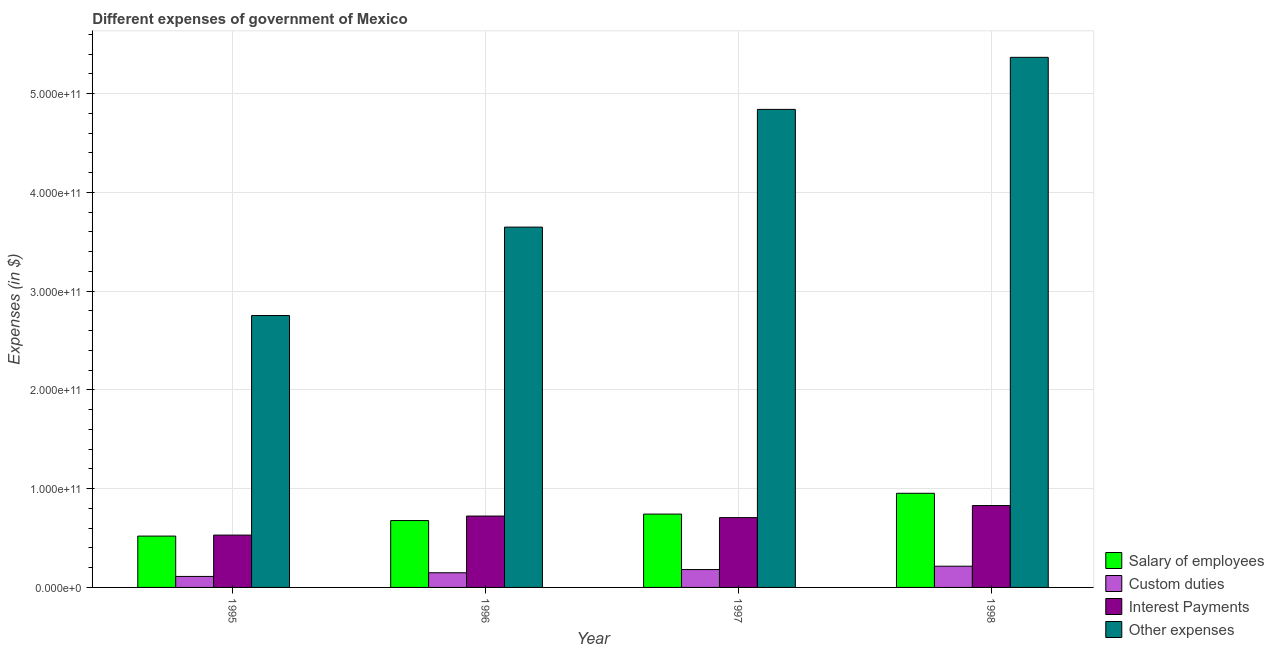How many different coloured bars are there?
Your answer should be very brief. 4. How many groups of bars are there?
Offer a terse response. 4. Are the number of bars per tick equal to the number of legend labels?
Give a very brief answer. Yes. Are the number of bars on each tick of the X-axis equal?
Your answer should be compact. Yes. How many bars are there on the 1st tick from the right?
Ensure brevity in your answer.  4. What is the label of the 1st group of bars from the left?
Provide a succinct answer. 1995. What is the amount spent on salary of employees in 1998?
Your response must be concise. 9.53e+1. Across all years, what is the maximum amount spent on interest payments?
Give a very brief answer. 8.29e+1. Across all years, what is the minimum amount spent on custom duties?
Your response must be concise. 1.11e+1. What is the total amount spent on custom duties in the graph?
Make the answer very short. 6.56e+1. What is the difference between the amount spent on salary of employees in 1997 and that in 1998?
Provide a short and direct response. -2.11e+1. What is the difference between the amount spent on salary of employees in 1995 and the amount spent on other expenses in 1998?
Your response must be concise. -4.33e+1. What is the average amount spent on custom duties per year?
Your answer should be compact. 1.64e+1. In the year 1998, what is the difference between the amount spent on other expenses and amount spent on custom duties?
Your response must be concise. 0. What is the ratio of the amount spent on custom duties in 1996 to that in 1997?
Offer a very short reply. 0.82. Is the amount spent on interest payments in 1995 less than that in 1998?
Your answer should be compact. Yes. Is the difference between the amount spent on other expenses in 1996 and 1998 greater than the difference between the amount spent on interest payments in 1996 and 1998?
Make the answer very short. No. What is the difference between the highest and the second highest amount spent on salary of employees?
Offer a terse response. 2.11e+1. What is the difference between the highest and the lowest amount spent on custom duties?
Your answer should be very brief. 1.03e+1. Is the sum of the amount spent on salary of employees in 1997 and 1998 greater than the maximum amount spent on other expenses across all years?
Keep it short and to the point. Yes. What does the 2nd bar from the left in 1998 represents?
Your answer should be very brief. Custom duties. What does the 1st bar from the right in 1998 represents?
Provide a succinct answer. Other expenses. Is it the case that in every year, the sum of the amount spent on salary of employees and amount spent on custom duties is greater than the amount spent on interest payments?
Offer a very short reply. Yes. How many bars are there?
Your answer should be very brief. 16. What is the difference between two consecutive major ticks on the Y-axis?
Provide a succinct answer. 1.00e+11. Does the graph contain any zero values?
Provide a short and direct response. No. Where does the legend appear in the graph?
Provide a succinct answer. Bottom right. What is the title of the graph?
Give a very brief answer. Different expenses of government of Mexico. Does "Quality Certification" appear as one of the legend labels in the graph?
Keep it short and to the point. No. What is the label or title of the X-axis?
Your answer should be compact. Year. What is the label or title of the Y-axis?
Make the answer very short. Expenses (in $). What is the Expenses (in $) of Salary of employees in 1995?
Keep it short and to the point. 5.20e+1. What is the Expenses (in $) in Custom duties in 1995?
Your answer should be compact. 1.11e+1. What is the Expenses (in $) of Interest Payments in 1995?
Offer a terse response. 5.30e+1. What is the Expenses (in $) of Other expenses in 1995?
Provide a short and direct response. 2.75e+11. What is the Expenses (in $) of Salary of employees in 1996?
Offer a very short reply. 6.77e+1. What is the Expenses (in $) of Custom duties in 1996?
Ensure brevity in your answer.  1.49e+1. What is the Expenses (in $) in Interest Payments in 1996?
Provide a short and direct response. 7.23e+1. What is the Expenses (in $) of Other expenses in 1996?
Provide a short and direct response. 3.65e+11. What is the Expenses (in $) of Salary of employees in 1997?
Your answer should be compact. 7.43e+1. What is the Expenses (in $) in Custom duties in 1997?
Offer a very short reply. 1.81e+1. What is the Expenses (in $) of Interest Payments in 1997?
Keep it short and to the point. 7.07e+1. What is the Expenses (in $) of Other expenses in 1997?
Give a very brief answer. 4.84e+11. What is the Expenses (in $) of Salary of employees in 1998?
Make the answer very short. 9.53e+1. What is the Expenses (in $) of Custom duties in 1998?
Your answer should be very brief. 2.15e+1. What is the Expenses (in $) in Interest Payments in 1998?
Your response must be concise. 8.29e+1. What is the Expenses (in $) of Other expenses in 1998?
Your answer should be very brief. 5.37e+11. Across all years, what is the maximum Expenses (in $) in Salary of employees?
Provide a short and direct response. 9.53e+1. Across all years, what is the maximum Expenses (in $) in Custom duties?
Provide a short and direct response. 2.15e+1. Across all years, what is the maximum Expenses (in $) in Interest Payments?
Your response must be concise. 8.29e+1. Across all years, what is the maximum Expenses (in $) of Other expenses?
Ensure brevity in your answer.  5.37e+11. Across all years, what is the minimum Expenses (in $) in Salary of employees?
Offer a terse response. 5.20e+1. Across all years, what is the minimum Expenses (in $) of Custom duties?
Provide a short and direct response. 1.11e+1. Across all years, what is the minimum Expenses (in $) in Interest Payments?
Offer a very short reply. 5.30e+1. Across all years, what is the minimum Expenses (in $) in Other expenses?
Your response must be concise. 2.75e+11. What is the total Expenses (in $) in Salary of employees in the graph?
Give a very brief answer. 2.89e+11. What is the total Expenses (in $) of Custom duties in the graph?
Provide a succinct answer. 6.56e+1. What is the total Expenses (in $) of Interest Payments in the graph?
Provide a short and direct response. 2.79e+11. What is the total Expenses (in $) in Other expenses in the graph?
Provide a short and direct response. 1.66e+12. What is the difference between the Expenses (in $) of Salary of employees in 1995 and that in 1996?
Ensure brevity in your answer.  -1.57e+1. What is the difference between the Expenses (in $) in Custom duties in 1995 and that in 1996?
Your answer should be very brief. -3.71e+09. What is the difference between the Expenses (in $) in Interest Payments in 1995 and that in 1996?
Your response must be concise. -1.93e+1. What is the difference between the Expenses (in $) in Other expenses in 1995 and that in 1996?
Your answer should be compact. -8.95e+1. What is the difference between the Expenses (in $) in Salary of employees in 1995 and that in 1997?
Ensure brevity in your answer.  -2.23e+1. What is the difference between the Expenses (in $) in Custom duties in 1995 and that in 1997?
Provide a short and direct response. -6.96e+09. What is the difference between the Expenses (in $) in Interest Payments in 1995 and that in 1997?
Make the answer very short. -1.77e+1. What is the difference between the Expenses (in $) in Other expenses in 1995 and that in 1997?
Make the answer very short. -2.09e+11. What is the difference between the Expenses (in $) of Salary of employees in 1995 and that in 1998?
Offer a terse response. -4.33e+1. What is the difference between the Expenses (in $) of Custom duties in 1995 and that in 1998?
Offer a very short reply. -1.03e+1. What is the difference between the Expenses (in $) of Interest Payments in 1995 and that in 1998?
Make the answer very short. -2.99e+1. What is the difference between the Expenses (in $) in Other expenses in 1995 and that in 1998?
Keep it short and to the point. -2.61e+11. What is the difference between the Expenses (in $) in Salary of employees in 1996 and that in 1997?
Make the answer very short. -6.55e+09. What is the difference between the Expenses (in $) of Custom duties in 1996 and that in 1997?
Your answer should be compact. -3.25e+09. What is the difference between the Expenses (in $) of Interest Payments in 1996 and that in 1997?
Provide a succinct answer. 1.58e+09. What is the difference between the Expenses (in $) in Other expenses in 1996 and that in 1997?
Offer a very short reply. -1.19e+11. What is the difference between the Expenses (in $) of Salary of employees in 1996 and that in 1998?
Offer a very short reply. -2.76e+1. What is the difference between the Expenses (in $) of Custom duties in 1996 and that in 1998?
Make the answer very short. -6.63e+09. What is the difference between the Expenses (in $) of Interest Payments in 1996 and that in 1998?
Provide a short and direct response. -1.06e+1. What is the difference between the Expenses (in $) of Other expenses in 1996 and that in 1998?
Keep it short and to the point. -1.72e+11. What is the difference between the Expenses (in $) of Salary of employees in 1997 and that in 1998?
Your answer should be very brief. -2.11e+1. What is the difference between the Expenses (in $) of Custom duties in 1997 and that in 1998?
Your response must be concise. -3.38e+09. What is the difference between the Expenses (in $) in Interest Payments in 1997 and that in 1998?
Your answer should be very brief. -1.22e+1. What is the difference between the Expenses (in $) of Other expenses in 1997 and that in 1998?
Ensure brevity in your answer.  -5.27e+1. What is the difference between the Expenses (in $) in Salary of employees in 1995 and the Expenses (in $) in Custom duties in 1996?
Ensure brevity in your answer.  3.71e+1. What is the difference between the Expenses (in $) of Salary of employees in 1995 and the Expenses (in $) of Interest Payments in 1996?
Give a very brief answer. -2.03e+1. What is the difference between the Expenses (in $) in Salary of employees in 1995 and the Expenses (in $) in Other expenses in 1996?
Provide a short and direct response. -3.13e+11. What is the difference between the Expenses (in $) of Custom duties in 1995 and the Expenses (in $) of Interest Payments in 1996?
Ensure brevity in your answer.  -6.11e+1. What is the difference between the Expenses (in $) of Custom duties in 1995 and the Expenses (in $) of Other expenses in 1996?
Keep it short and to the point. -3.54e+11. What is the difference between the Expenses (in $) in Interest Payments in 1995 and the Expenses (in $) in Other expenses in 1996?
Your answer should be very brief. -3.12e+11. What is the difference between the Expenses (in $) in Salary of employees in 1995 and the Expenses (in $) in Custom duties in 1997?
Your answer should be very brief. 3.39e+1. What is the difference between the Expenses (in $) of Salary of employees in 1995 and the Expenses (in $) of Interest Payments in 1997?
Your answer should be very brief. -1.87e+1. What is the difference between the Expenses (in $) in Salary of employees in 1995 and the Expenses (in $) in Other expenses in 1997?
Provide a short and direct response. -4.32e+11. What is the difference between the Expenses (in $) of Custom duties in 1995 and the Expenses (in $) of Interest Payments in 1997?
Offer a terse response. -5.96e+1. What is the difference between the Expenses (in $) of Custom duties in 1995 and the Expenses (in $) of Other expenses in 1997?
Your answer should be compact. -4.73e+11. What is the difference between the Expenses (in $) of Interest Payments in 1995 and the Expenses (in $) of Other expenses in 1997?
Your answer should be compact. -4.31e+11. What is the difference between the Expenses (in $) in Salary of employees in 1995 and the Expenses (in $) in Custom duties in 1998?
Provide a succinct answer. 3.05e+1. What is the difference between the Expenses (in $) of Salary of employees in 1995 and the Expenses (in $) of Interest Payments in 1998?
Your response must be concise. -3.09e+1. What is the difference between the Expenses (in $) in Salary of employees in 1995 and the Expenses (in $) in Other expenses in 1998?
Your response must be concise. -4.85e+11. What is the difference between the Expenses (in $) in Custom duties in 1995 and the Expenses (in $) in Interest Payments in 1998?
Give a very brief answer. -7.18e+1. What is the difference between the Expenses (in $) in Custom duties in 1995 and the Expenses (in $) in Other expenses in 1998?
Give a very brief answer. -5.26e+11. What is the difference between the Expenses (in $) in Interest Payments in 1995 and the Expenses (in $) in Other expenses in 1998?
Offer a very short reply. -4.84e+11. What is the difference between the Expenses (in $) in Salary of employees in 1996 and the Expenses (in $) in Custom duties in 1997?
Provide a short and direct response. 4.96e+1. What is the difference between the Expenses (in $) in Salary of employees in 1996 and the Expenses (in $) in Interest Payments in 1997?
Provide a succinct answer. -2.99e+09. What is the difference between the Expenses (in $) of Salary of employees in 1996 and the Expenses (in $) of Other expenses in 1997?
Offer a terse response. -4.16e+11. What is the difference between the Expenses (in $) in Custom duties in 1996 and the Expenses (in $) in Interest Payments in 1997?
Offer a very short reply. -5.59e+1. What is the difference between the Expenses (in $) in Custom duties in 1996 and the Expenses (in $) in Other expenses in 1997?
Provide a succinct answer. -4.69e+11. What is the difference between the Expenses (in $) in Interest Payments in 1996 and the Expenses (in $) in Other expenses in 1997?
Keep it short and to the point. -4.12e+11. What is the difference between the Expenses (in $) of Salary of employees in 1996 and the Expenses (in $) of Custom duties in 1998?
Your answer should be very brief. 4.62e+1. What is the difference between the Expenses (in $) in Salary of employees in 1996 and the Expenses (in $) in Interest Payments in 1998?
Give a very brief answer. -1.52e+1. What is the difference between the Expenses (in $) of Salary of employees in 1996 and the Expenses (in $) of Other expenses in 1998?
Your response must be concise. -4.69e+11. What is the difference between the Expenses (in $) of Custom duties in 1996 and the Expenses (in $) of Interest Payments in 1998?
Make the answer very short. -6.81e+1. What is the difference between the Expenses (in $) in Custom duties in 1996 and the Expenses (in $) in Other expenses in 1998?
Provide a succinct answer. -5.22e+11. What is the difference between the Expenses (in $) of Interest Payments in 1996 and the Expenses (in $) of Other expenses in 1998?
Offer a very short reply. -4.65e+11. What is the difference between the Expenses (in $) of Salary of employees in 1997 and the Expenses (in $) of Custom duties in 1998?
Provide a succinct answer. 5.28e+1. What is the difference between the Expenses (in $) in Salary of employees in 1997 and the Expenses (in $) in Interest Payments in 1998?
Make the answer very short. -8.64e+09. What is the difference between the Expenses (in $) of Salary of employees in 1997 and the Expenses (in $) of Other expenses in 1998?
Offer a terse response. -4.63e+11. What is the difference between the Expenses (in $) of Custom duties in 1997 and the Expenses (in $) of Interest Payments in 1998?
Make the answer very short. -6.48e+1. What is the difference between the Expenses (in $) of Custom duties in 1997 and the Expenses (in $) of Other expenses in 1998?
Keep it short and to the point. -5.19e+11. What is the difference between the Expenses (in $) of Interest Payments in 1997 and the Expenses (in $) of Other expenses in 1998?
Make the answer very short. -4.66e+11. What is the average Expenses (in $) of Salary of employees per year?
Ensure brevity in your answer.  7.23e+1. What is the average Expenses (in $) in Custom duties per year?
Provide a short and direct response. 1.64e+1. What is the average Expenses (in $) of Interest Payments per year?
Your response must be concise. 6.97e+1. What is the average Expenses (in $) of Other expenses per year?
Your response must be concise. 4.15e+11. In the year 1995, what is the difference between the Expenses (in $) in Salary of employees and Expenses (in $) in Custom duties?
Make the answer very short. 4.09e+1. In the year 1995, what is the difference between the Expenses (in $) in Salary of employees and Expenses (in $) in Interest Payments?
Ensure brevity in your answer.  -1.01e+09. In the year 1995, what is the difference between the Expenses (in $) of Salary of employees and Expenses (in $) of Other expenses?
Your response must be concise. -2.23e+11. In the year 1995, what is the difference between the Expenses (in $) in Custom duties and Expenses (in $) in Interest Payments?
Give a very brief answer. -4.19e+1. In the year 1995, what is the difference between the Expenses (in $) of Custom duties and Expenses (in $) of Other expenses?
Offer a very short reply. -2.64e+11. In the year 1995, what is the difference between the Expenses (in $) of Interest Payments and Expenses (in $) of Other expenses?
Your answer should be compact. -2.22e+11. In the year 1996, what is the difference between the Expenses (in $) of Salary of employees and Expenses (in $) of Custom duties?
Keep it short and to the point. 5.29e+1. In the year 1996, what is the difference between the Expenses (in $) in Salary of employees and Expenses (in $) in Interest Payments?
Your response must be concise. -4.56e+09. In the year 1996, what is the difference between the Expenses (in $) in Salary of employees and Expenses (in $) in Other expenses?
Offer a very short reply. -2.97e+11. In the year 1996, what is the difference between the Expenses (in $) in Custom duties and Expenses (in $) in Interest Payments?
Your answer should be compact. -5.74e+1. In the year 1996, what is the difference between the Expenses (in $) of Custom duties and Expenses (in $) of Other expenses?
Provide a succinct answer. -3.50e+11. In the year 1996, what is the difference between the Expenses (in $) of Interest Payments and Expenses (in $) of Other expenses?
Offer a very short reply. -2.93e+11. In the year 1997, what is the difference between the Expenses (in $) in Salary of employees and Expenses (in $) in Custom duties?
Offer a very short reply. 5.62e+1. In the year 1997, what is the difference between the Expenses (in $) of Salary of employees and Expenses (in $) of Interest Payments?
Make the answer very short. 3.56e+09. In the year 1997, what is the difference between the Expenses (in $) of Salary of employees and Expenses (in $) of Other expenses?
Your answer should be compact. -4.10e+11. In the year 1997, what is the difference between the Expenses (in $) in Custom duties and Expenses (in $) in Interest Payments?
Make the answer very short. -5.26e+1. In the year 1997, what is the difference between the Expenses (in $) of Custom duties and Expenses (in $) of Other expenses?
Your answer should be compact. -4.66e+11. In the year 1997, what is the difference between the Expenses (in $) in Interest Payments and Expenses (in $) in Other expenses?
Your answer should be very brief. -4.13e+11. In the year 1998, what is the difference between the Expenses (in $) of Salary of employees and Expenses (in $) of Custom duties?
Make the answer very short. 7.39e+1. In the year 1998, what is the difference between the Expenses (in $) in Salary of employees and Expenses (in $) in Interest Payments?
Provide a succinct answer. 1.24e+1. In the year 1998, what is the difference between the Expenses (in $) in Salary of employees and Expenses (in $) in Other expenses?
Your answer should be compact. -4.42e+11. In the year 1998, what is the difference between the Expenses (in $) of Custom duties and Expenses (in $) of Interest Payments?
Provide a succinct answer. -6.14e+1. In the year 1998, what is the difference between the Expenses (in $) of Custom duties and Expenses (in $) of Other expenses?
Keep it short and to the point. -5.15e+11. In the year 1998, what is the difference between the Expenses (in $) in Interest Payments and Expenses (in $) in Other expenses?
Offer a terse response. -4.54e+11. What is the ratio of the Expenses (in $) of Salary of employees in 1995 to that in 1996?
Provide a short and direct response. 0.77. What is the ratio of the Expenses (in $) of Custom duties in 1995 to that in 1996?
Offer a terse response. 0.75. What is the ratio of the Expenses (in $) of Interest Payments in 1995 to that in 1996?
Provide a short and direct response. 0.73. What is the ratio of the Expenses (in $) of Other expenses in 1995 to that in 1996?
Offer a terse response. 0.75. What is the ratio of the Expenses (in $) of Salary of employees in 1995 to that in 1997?
Your answer should be compact. 0.7. What is the ratio of the Expenses (in $) of Custom duties in 1995 to that in 1997?
Ensure brevity in your answer.  0.62. What is the ratio of the Expenses (in $) of Interest Payments in 1995 to that in 1997?
Give a very brief answer. 0.75. What is the ratio of the Expenses (in $) of Other expenses in 1995 to that in 1997?
Your answer should be compact. 0.57. What is the ratio of the Expenses (in $) of Salary of employees in 1995 to that in 1998?
Your answer should be compact. 0.55. What is the ratio of the Expenses (in $) in Custom duties in 1995 to that in 1998?
Your answer should be very brief. 0.52. What is the ratio of the Expenses (in $) of Interest Payments in 1995 to that in 1998?
Give a very brief answer. 0.64. What is the ratio of the Expenses (in $) of Other expenses in 1995 to that in 1998?
Provide a short and direct response. 0.51. What is the ratio of the Expenses (in $) in Salary of employees in 1996 to that in 1997?
Offer a terse response. 0.91. What is the ratio of the Expenses (in $) of Custom duties in 1996 to that in 1997?
Your answer should be very brief. 0.82. What is the ratio of the Expenses (in $) in Interest Payments in 1996 to that in 1997?
Offer a terse response. 1.02. What is the ratio of the Expenses (in $) of Other expenses in 1996 to that in 1997?
Your answer should be very brief. 0.75. What is the ratio of the Expenses (in $) of Salary of employees in 1996 to that in 1998?
Offer a very short reply. 0.71. What is the ratio of the Expenses (in $) in Custom duties in 1996 to that in 1998?
Give a very brief answer. 0.69. What is the ratio of the Expenses (in $) of Interest Payments in 1996 to that in 1998?
Keep it short and to the point. 0.87. What is the ratio of the Expenses (in $) in Other expenses in 1996 to that in 1998?
Provide a short and direct response. 0.68. What is the ratio of the Expenses (in $) of Salary of employees in 1997 to that in 1998?
Make the answer very short. 0.78. What is the ratio of the Expenses (in $) in Custom duties in 1997 to that in 1998?
Ensure brevity in your answer.  0.84. What is the ratio of the Expenses (in $) of Interest Payments in 1997 to that in 1998?
Give a very brief answer. 0.85. What is the ratio of the Expenses (in $) of Other expenses in 1997 to that in 1998?
Ensure brevity in your answer.  0.9. What is the difference between the highest and the second highest Expenses (in $) of Salary of employees?
Your answer should be compact. 2.11e+1. What is the difference between the highest and the second highest Expenses (in $) of Custom duties?
Offer a terse response. 3.38e+09. What is the difference between the highest and the second highest Expenses (in $) in Interest Payments?
Ensure brevity in your answer.  1.06e+1. What is the difference between the highest and the second highest Expenses (in $) of Other expenses?
Your answer should be compact. 5.27e+1. What is the difference between the highest and the lowest Expenses (in $) of Salary of employees?
Provide a succinct answer. 4.33e+1. What is the difference between the highest and the lowest Expenses (in $) of Custom duties?
Your response must be concise. 1.03e+1. What is the difference between the highest and the lowest Expenses (in $) of Interest Payments?
Your answer should be very brief. 2.99e+1. What is the difference between the highest and the lowest Expenses (in $) of Other expenses?
Offer a very short reply. 2.61e+11. 